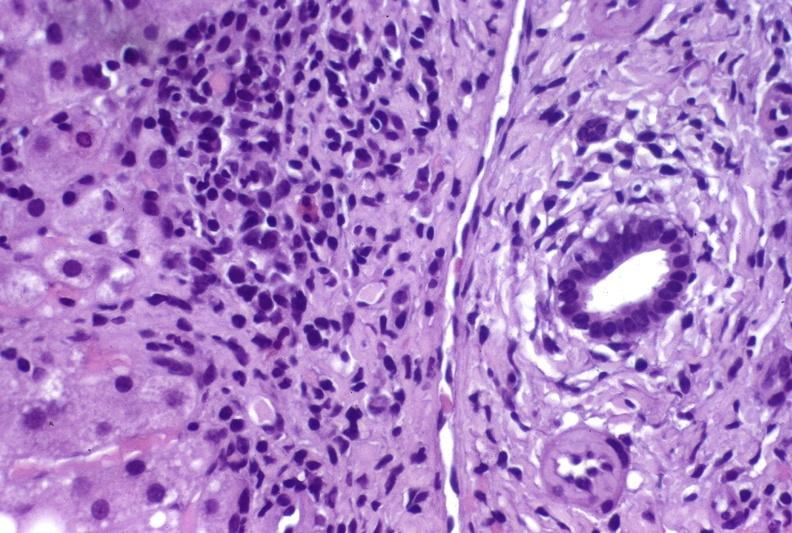what is present?
Answer the question using a single word or phrase. Hepatobiliary 